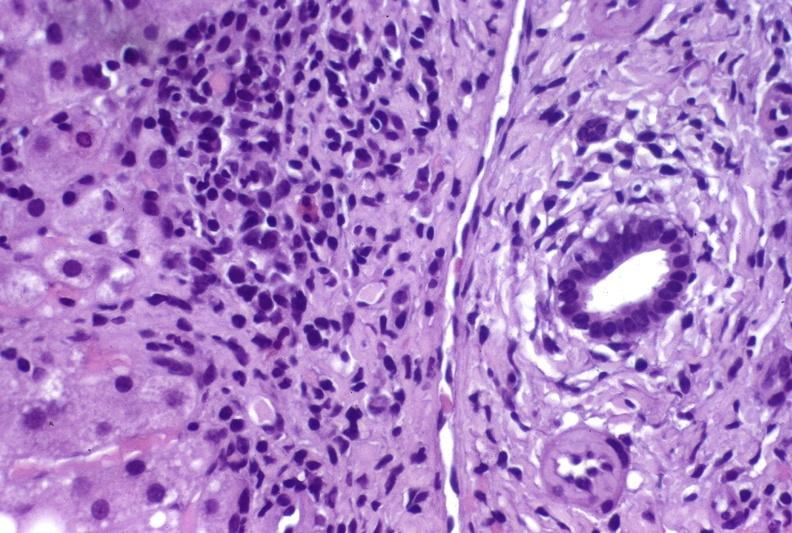what is present?
Answer the question using a single word or phrase. Hepatobiliary 